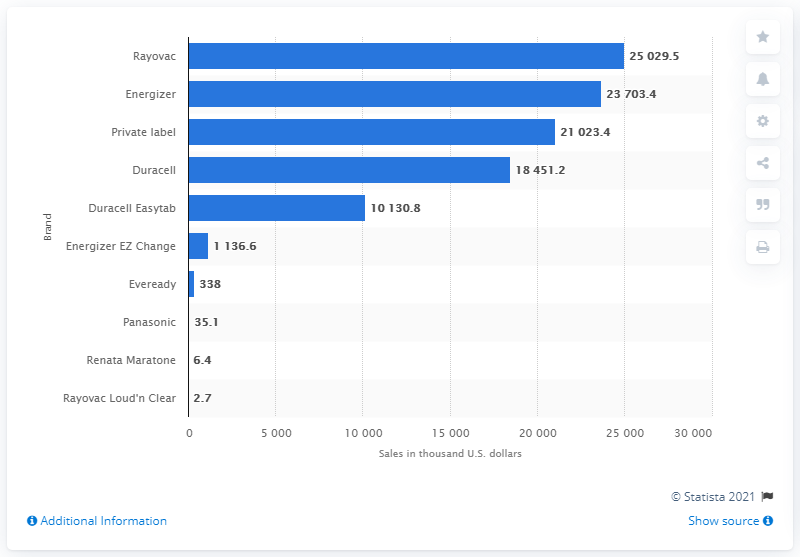Outline some significant characteristics in this image. In 2013, the leading brand of zinc air batteries in the United States was Rayovac. In 2013, Rayovac generated $250,29.50 in revenue. 